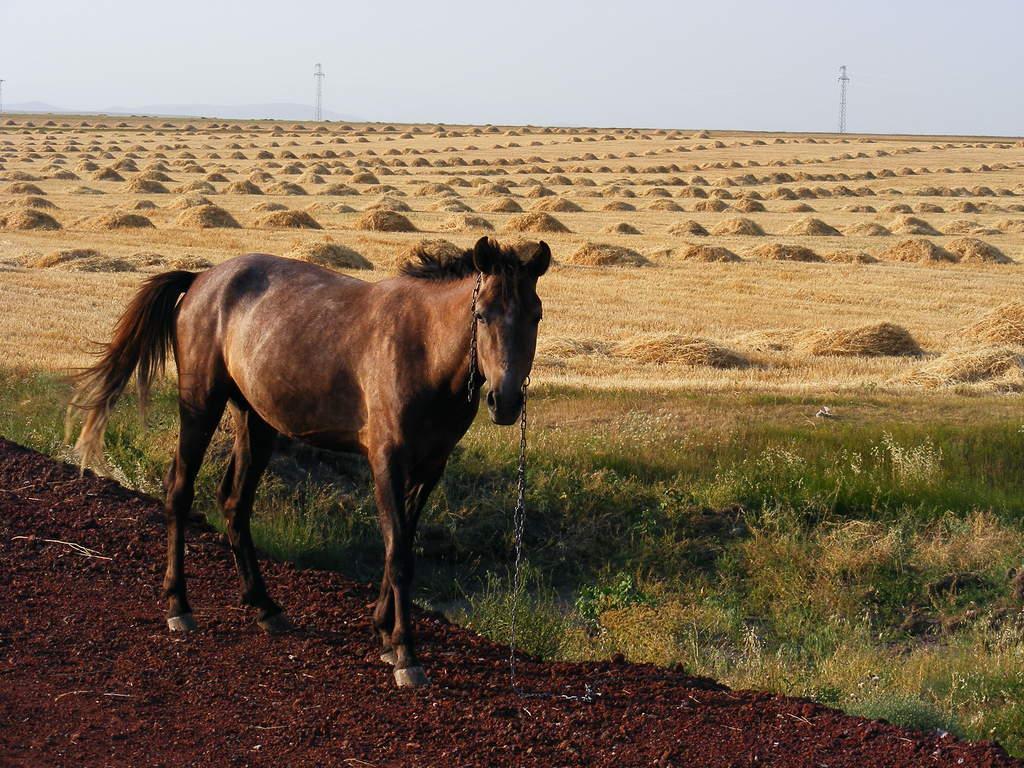Could you give a brief overview of what you see in this image? In this image I can see an animal which is in brown color. To the side of an animal I can see the green and dried grass. In the background I can see the sky. 